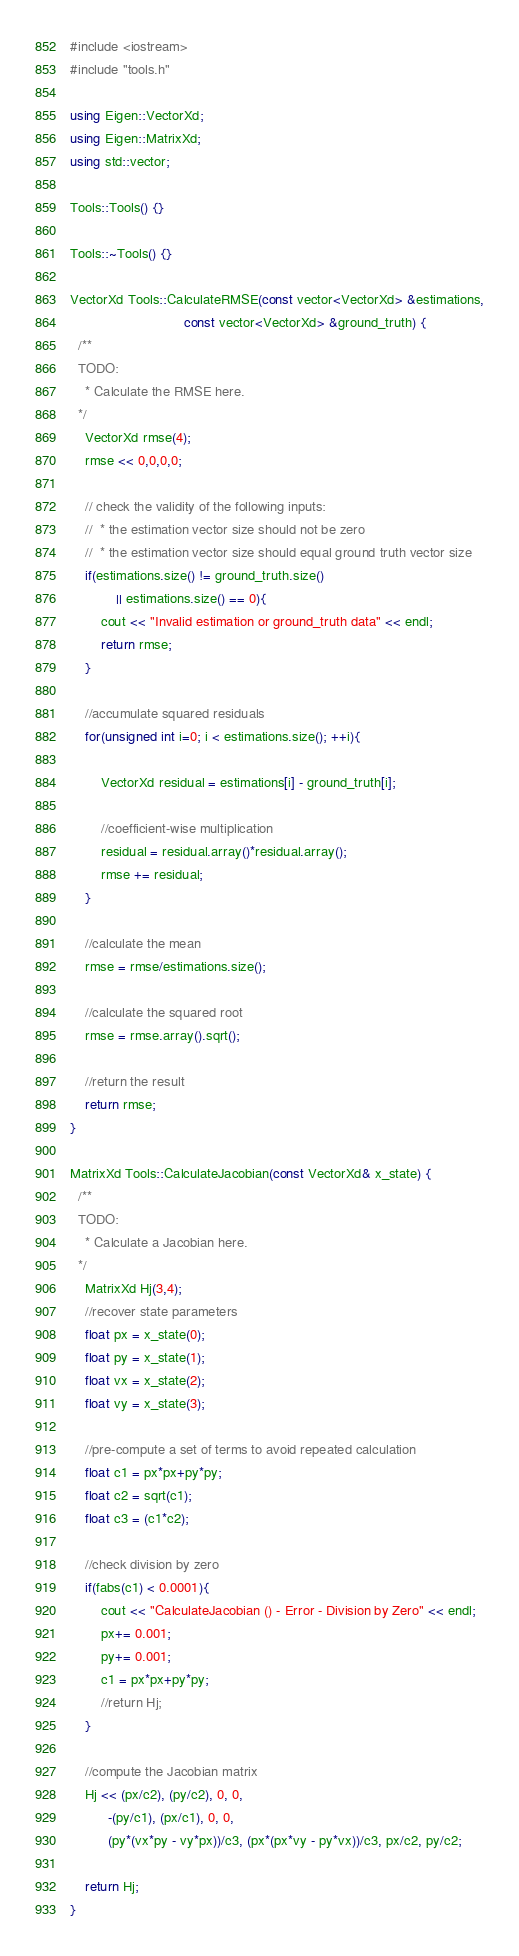Convert code to text. <code><loc_0><loc_0><loc_500><loc_500><_C++_>#include <iostream>
#include "tools.h"

using Eigen::VectorXd;
using Eigen::MatrixXd;
using std::vector;

Tools::Tools() {}

Tools::~Tools() {}

VectorXd Tools::CalculateRMSE(const vector<VectorXd> &estimations,
                              const vector<VectorXd> &ground_truth) {
  /**
  TODO:
    * Calculate the RMSE here.
  */
	VectorXd rmse(4);
	rmse << 0,0,0,0;

	// check the validity of the following inputs:
	//  * the estimation vector size should not be zero
	//  * the estimation vector size should equal ground truth vector size
	if(estimations.size() != ground_truth.size()
			|| estimations.size() == 0){
		cout << "Invalid estimation or ground_truth data" << endl;
		return rmse;
	}

	//accumulate squared residuals
	for(unsigned int i=0; i < estimations.size(); ++i){

		VectorXd residual = estimations[i] - ground_truth[i];

		//coefficient-wise multiplication
		residual = residual.array()*residual.array();
		rmse += residual;
	}

	//calculate the mean
	rmse = rmse/estimations.size();

	//calculate the squared root
	rmse = rmse.array().sqrt();

	//return the result
	return rmse;
}

MatrixXd Tools::CalculateJacobian(const VectorXd& x_state) {
  /**
  TODO:
    * Calculate a Jacobian here.
  */
	MatrixXd Hj(3,4);
	//recover state parameters
	float px = x_state(0);
	float py = x_state(1);
	float vx = x_state(2);
	float vy = x_state(3);

	//pre-compute a set of terms to avoid repeated calculation
	float c1 = px*px+py*py;
	float c2 = sqrt(c1);
	float c3 = (c1*c2);

	//check division by zero
	if(fabs(c1) < 0.0001){
		cout << "CalculateJacobian () - Error - Division by Zero" << endl;
		px+= 0.001;
		py+= 0.001;
		c1 = px*px+py*py;
		//return Hj;
	}

	//compute the Jacobian matrix
	Hj << (px/c2), (py/c2), 0, 0,
		  -(py/c1), (px/c1), 0, 0,
		  (py*(vx*py - vy*px))/c3, (px*(px*vy - py*vx))/c3, px/c2, py/c2;

	return Hj;
}
</code> 